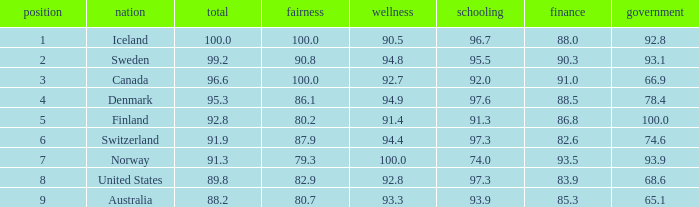What's the health score with justice being 80.7 93.3. 